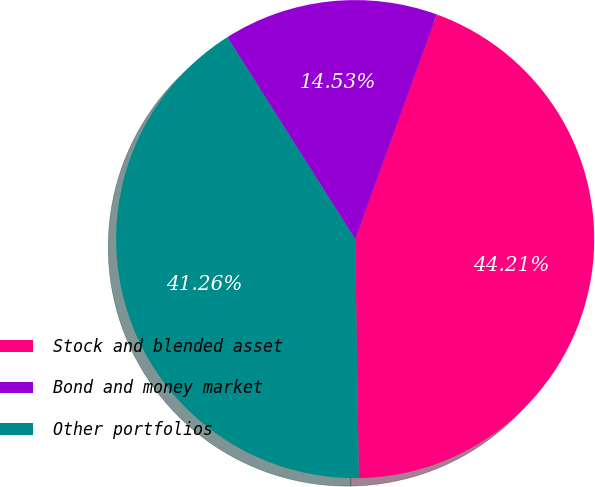Convert chart to OTSL. <chart><loc_0><loc_0><loc_500><loc_500><pie_chart><fcel>Stock and blended asset<fcel>Bond and money market<fcel>Other portfolios<nl><fcel>44.21%<fcel>14.53%<fcel>41.26%<nl></chart> 